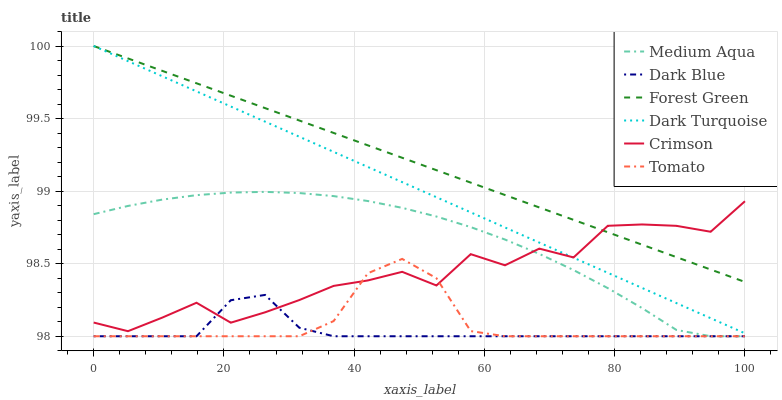Does Dark Blue have the minimum area under the curve?
Answer yes or no. Yes. Does Forest Green have the maximum area under the curve?
Answer yes or no. Yes. Does Dark Turquoise have the minimum area under the curve?
Answer yes or no. No. Does Dark Turquoise have the maximum area under the curve?
Answer yes or no. No. Is Forest Green the smoothest?
Answer yes or no. Yes. Is Crimson the roughest?
Answer yes or no. Yes. Is Dark Turquoise the smoothest?
Answer yes or no. No. Is Dark Turquoise the roughest?
Answer yes or no. No. Does Tomato have the lowest value?
Answer yes or no. Yes. Does Dark Turquoise have the lowest value?
Answer yes or no. No. Does Forest Green have the highest value?
Answer yes or no. Yes. Does Dark Blue have the highest value?
Answer yes or no. No. Is Medium Aqua less than Forest Green?
Answer yes or no. Yes. Is Dark Turquoise greater than Medium Aqua?
Answer yes or no. Yes. Does Medium Aqua intersect Dark Blue?
Answer yes or no. Yes. Is Medium Aqua less than Dark Blue?
Answer yes or no. No. Is Medium Aqua greater than Dark Blue?
Answer yes or no. No. Does Medium Aqua intersect Forest Green?
Answer yes or no. No. 